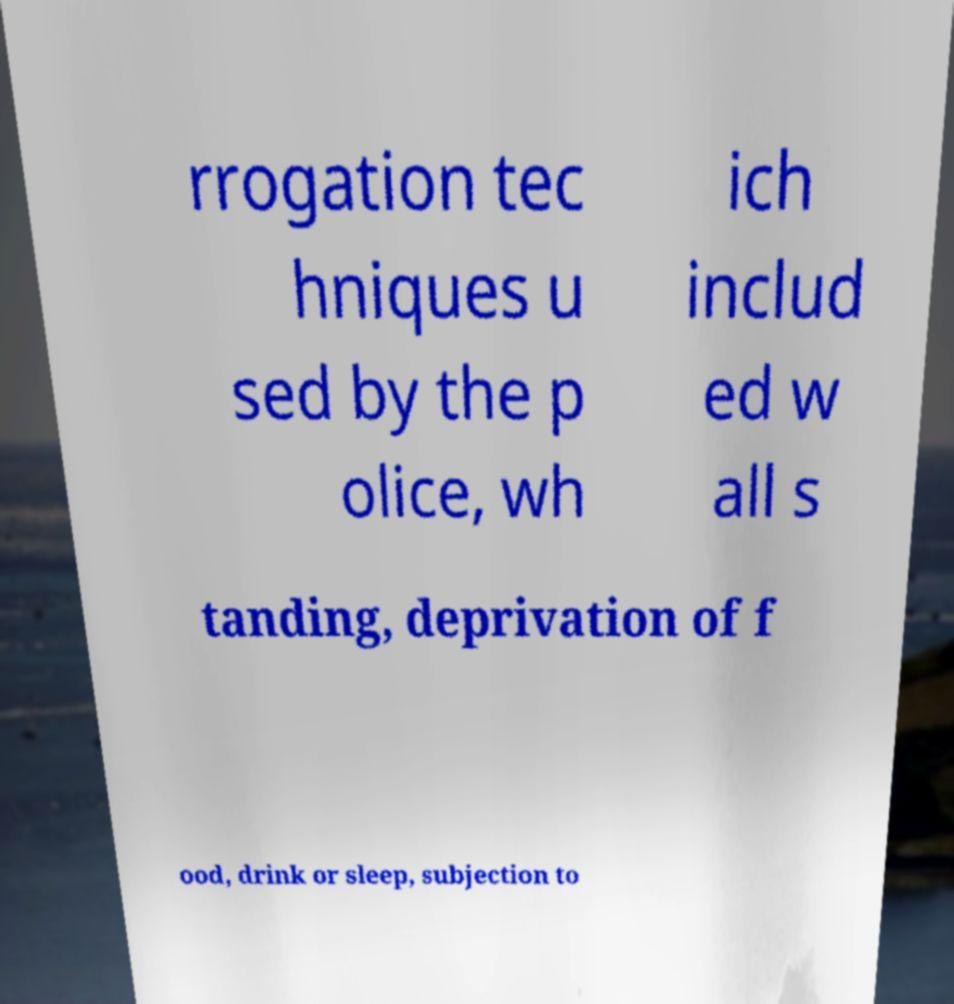What messages or text are displayed in this image? I need them in a readable, typed format. rrogation tec hniques u sed by the p olice, wh ich includ ed w all s tanding, deprivation of f ood, drink or sleep, subjection to 